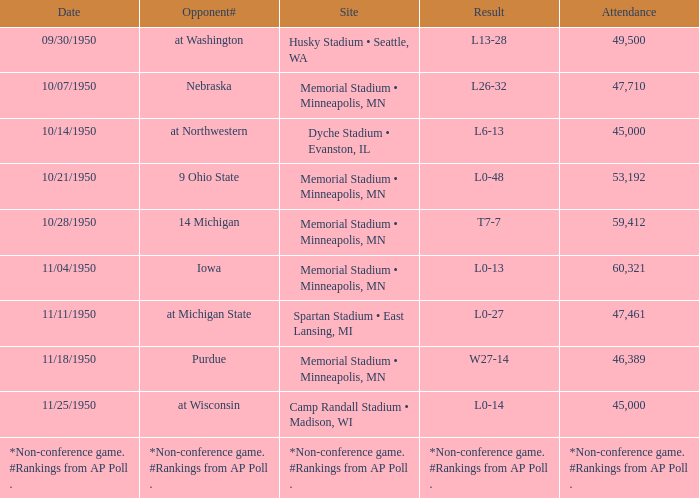When the score is 10-13, what is the number of attendees? 60321.0. Parse the table in full. {'header': ['Date', 'Opponent#', 'Site', 'Result', 'Attendance'], 'rows': [['09/30/1950', 'at Washington', 'Husky Stadium • Seattle, WA', 'L13-28', '49,500'], ['10/07/1950', 'Nebraska', 'Memorial Stadium • Minneapolis, MN', 'L26-32', '47,710'], ['10/14/1950', 'at Northwestern', 'Dyche Stadium • Evanston, IL', 'L6-13', '45,000'], ['10/21/1950', '9 Ohio State', 'Memorial Stadium • Minneapolis, MN', 'L0-48', '53,192'], ['10/28/1950', '14 Michigan', 'Memorial Stadium • Minneapolis, MN', 'T7-7', '59,412'], ['11/04/1950', 'Iowa', 'Memorial Stadium • Minneapolis, MN', 'L0-13', '60,321'], ['11/11/1950', 'at Michigan State', 'Spartan Stadium • East Lansing, MI', 'L0-27', '47,461'], ['11/18/1950', 'Purdue', 'Memorial Stadium • Minneapolis, MN', 'W27-14', '46,389'], ['11/25/1950', 'at Wisconsin', 'Camp Randall Stadium • Madison, WI', 'L0-14', '45,000'], ['*Non-conference game. #Rankings from AP Poll .', '*Non-conference game. #Rankings from AP Poll .', '*Non-conference game. #Rankings from AP Poll .', '*Non-conference game. #Rankings from AP Poll .', '*Non-conference game. #Rankings from AP Poll .']]} 